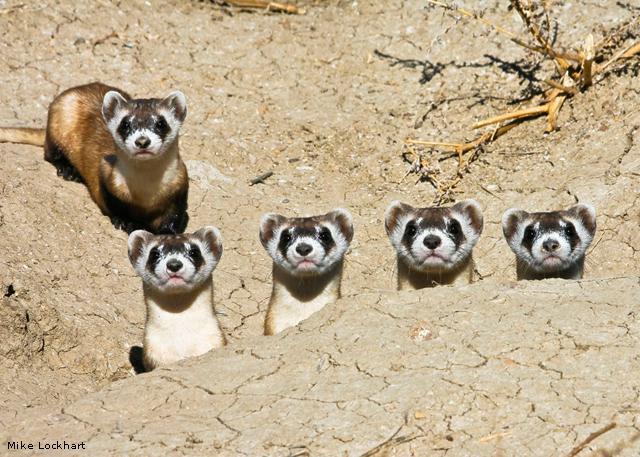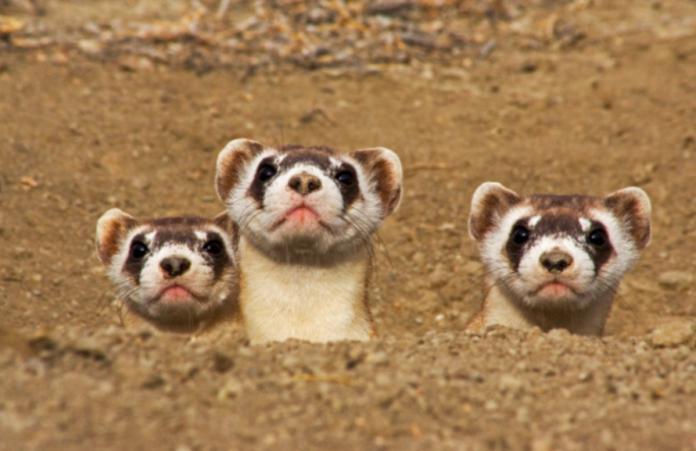The first image is the image on the left, the second image is the image on the right. Evaluate the accuracy of this statement regarding the images: "Exactly one image shows exactly three ferrets poking their heads up above the ground.". Is it true? Answer yes or no. Yes. The first image is the image on the left, the second image is the image on the right. Considering the images on both sides, is "There are more than five prairie dogs poking up from the ground." valid? Answer yes or no. Yes. 